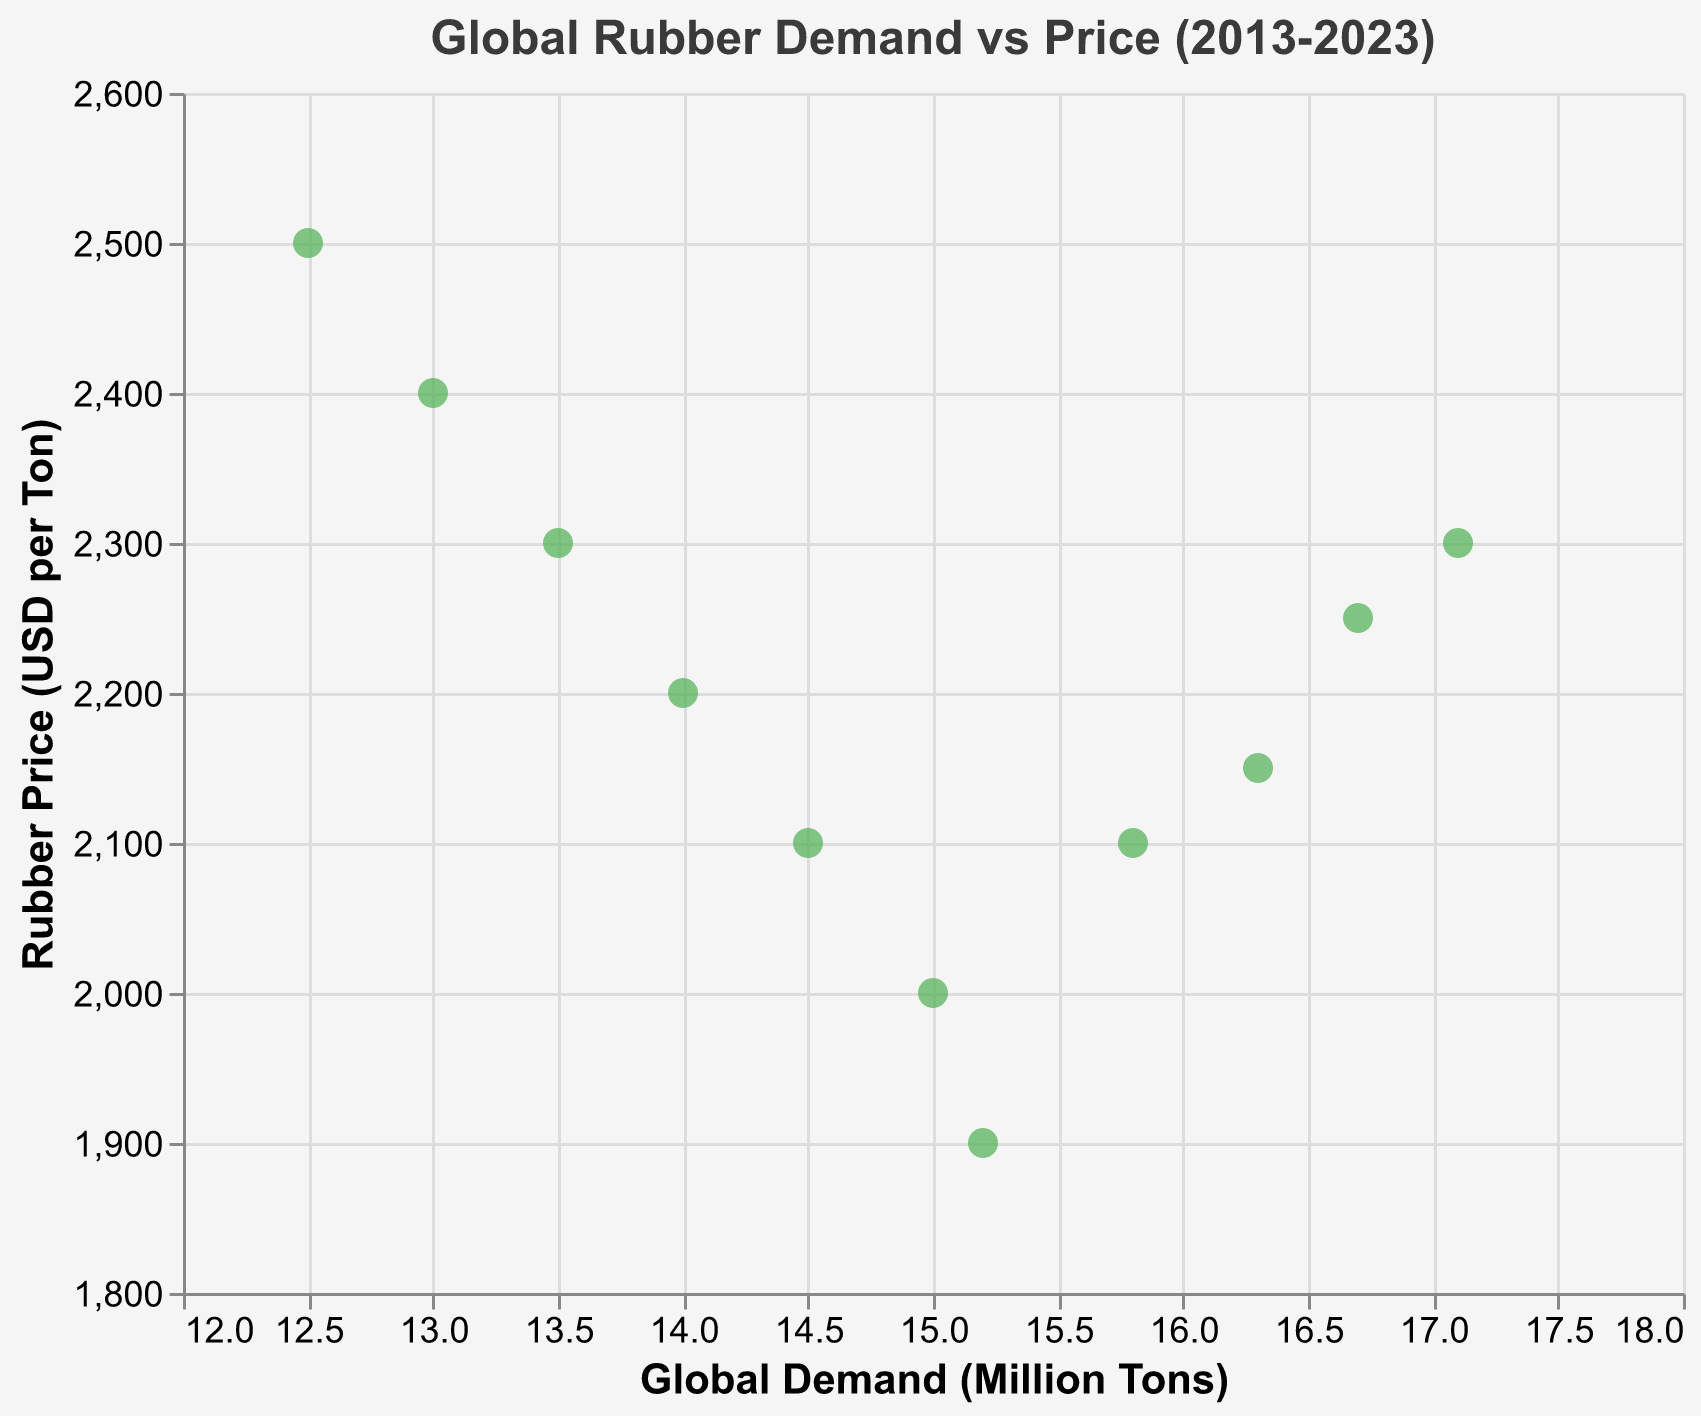What is the title of the scatter plot? The title of the scatter plot is located at the top center of the figure. We can directly read it from there.
Answer: Global Rubber Demand vs Price (2013-2023) How many data points are displayed in the scatter plot? Each data point represents a year from 2013 to 2023. By counting the number of points in the plot, we can determine the total amount.
Answer: 11 What is the highest rubber price recorded in the scatter plot? By examining the y-axis (Rubber Price in USD per Ton) and identifying the highest point, we find the maximum value.
Answer: 2500 In which year did the rubber price drop to its lowest point? By checking the y-axis for the lowest value of the Rubber Price and looking at the tooltip or corresponding point, we find the year 2019.
Answer: 2019 Is there a general trend between global demand and rubber price over the years? Observing the distribution of the points, we notice that as global demand increases, the rubber price tends to decrease at first and then stabilize.
Answer: Decreasing then stabilizing What was the rubber price when the global demand reached 15 million tons? We locate the point on the scatter plot where the x-axis (Global Demand in Million Tons) is 15 and check the y-value.
Answer: 2000 How did the rubber price change between 2020 and 2021? We find the points for the years 2020 and 2021 on the scatter plot and compare their y-values. The rubber price increased from 2100 to 2150 USD per ton.
Answer: Increased by 50 What was the average global demand from 2013 to 2023? We calculate the sum of global demand values and divide by the number of years. (12.5 + 13 + 13.5 + 14 + 14.5 + 15 + 15.2 + 15.8 + 16.3 + 16.7 + 17.1) / 11 = 165.6 / 11
Answer: 15.05 How does the rubber price in 2020 compare to that in 2019? By comparing the y-values of the points for the years 2019 and 2020 on the scatter plot, we see that the price increased from 1900 to 2100 USD per ton.
Answer: Increased by 200 What is the range of global demand presented in the scatter plot? The x-axis ranges from the lowest value (12.5 million tons in 2013) to the highest value (17.1 million tons in 2023).
Answer: 4.6 million tons 